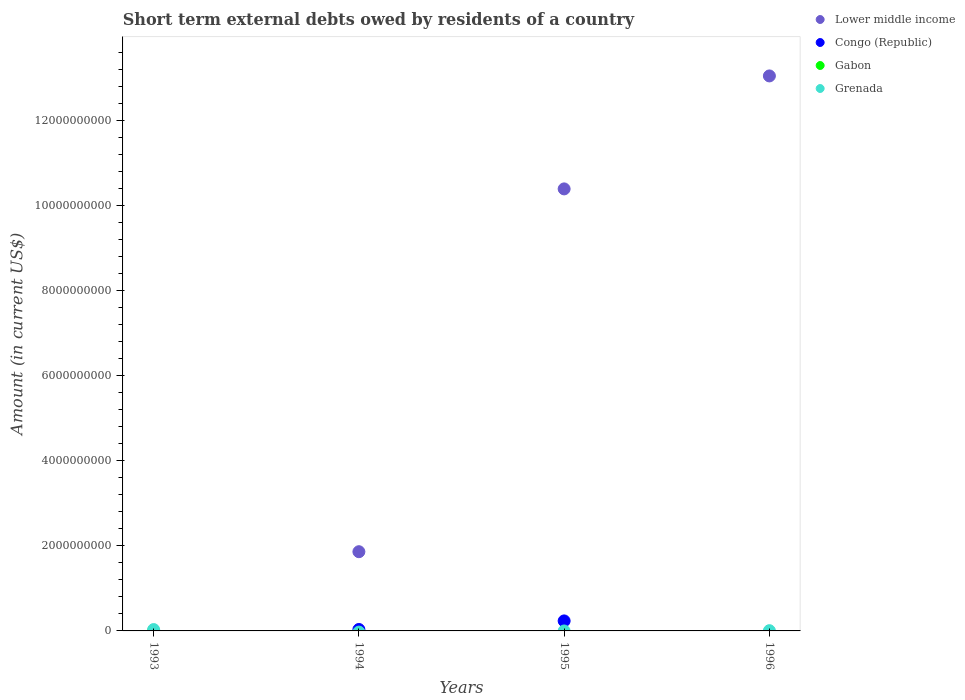How many different coloured dotlines are there?
Provide a succinct answer. 3. What is the amount of short-term external debts owed by residents in Grenada in 1995?
Provide a succinct answer. 0. Across all years, what is the maximum amount of short-term external debts owed by residents in Congo (Republic)?
Your response must be concise. 2.36e+08. Across all years, what is the minimum amount of short-term external debts owed by residents in Gabon?
Provide a succinct answer. 0. What is the total amount of short-term external debts owed by residents in Grenada in the graph?
Your answer should be compact. 3.74e+07. What is the difference between the amount of short-term external debts owed by residents in Grenada in 1993 and that in 1996?
Your response must be concise. 2.60e+07. What is the difference between the amount of short-term external debts owed by residents in Congo (Republic) in 1995 and the amount of short-term external debts owed by residents in Lower middle income in 1996?
Make the answer very short. -1.28e+1. What is the average amount of short-term external debts owed by residents in Grenada per year?
Your answer should be very brief. 9.34e+06. In the year 1994, what is the difference between the amount of short-term external debts owed by residents in Lower middle income and amount of short-term external debts owed by residents in Congo (Republic)?
Your answer should be very brief. 1.83e+09. In how many years, is the amount of short-term external debts owed by residents in Lower middle income greater than 9200000000 US$?
Offer a very short reply. 2. Is the amount of short-term external debts owed by residents in Lower middle income in 1994 less than that in 1996?
Your answer should be very brief. Yes. What is the difference between the highest and the lowest amount of short-term external debts owed by residents in Lower middle income?
Give a very brief answer. 1.31e+1. In how many years, is the amount of short-term external debts owed by residents in Congo (Republic) greater than the average amount of short-term external debts owed by residents in Congo (Republic) taken over all years?
Provide a short and direct response. 1. Is it the case that in every year, the sum of the amount of short-term external debts owed by residents in Congo (Republic) and amount of short-term external debts owed by residents in Gabon  is greater than the sum of amount of short-term external debts owed by residents in Grenada and amount of short-term external debts owed by residents in Lower middle income?
Give a very brief answer. No. Does the amount of short-term external debts owed by residents in Grenada monotonically increase over the years?
Offer a very short reply. No. Is the amount of short-term external debts owed by residents in Grenada strictly less than the amount of short-term external debts owed by residents in Gabon over the years?
Provide a short and direct response. No. How many years are there in the graph?
Make the answer very short. 4. Does the graph contain any zero values?
Offer a very short reply. Yes. Does the graph contain grids?
Offer a very short reply. No. Where does the legend appear in the graph?
Provide a succinct answer. Top right. How many legend labels are there?
Provide a short and direct response. 4. What is the title of the graph?
Offer a very short reply. Short term external debts owed by residents of a country. What is the label or title of the X-axis?
Your answer should be compact. Years. What is the label or title of the Y-axis?
Ensure brevity in your answer.  Amount (in current US$). What is the Amount (in current US$) of Grenada in 1993?
Offer a very short reply. 3.17e+07. What is the Amount (in current US$) in Lower middle income in 1994?
Make the answer very short. 1.86e+09. What is the Amount (in current US$) of Congo (Republic) in 1994?
Offer a very short reply. 3.41e+07. What is the Amount (in current US$) in Gabon in 1994?
Offer a very short reply. 0. What is the Amount (in current US$) in Grenada in 1994?
Provide a short and direct response. 0. What is the Amount (in current US$) of Lower middle income in 1995?
Ensure brevity in your answer.  1.04e+1. What is the Amount (in current US$) in Congo (Republic) in 1995?
Offer a very short reply. 2.36e+08. What is the Amount (in current US$) in Gabon in 1995?
Offer a very short reply. 0. What is the Amount (in current US$) in Grenada in 1995?
Give a very brief answer. 0. What is the Amount (in current US$) of Lower middle income in 1996?
Give a very brief answer. 1.31e+1. What is the Amount (in current US$) in Gabon in 1996?
Your answer should be very brief. 0. What is the Amount (in current US$) in Grenada in 1996?
Offer a terse response. 5.66e+06. Across all years, what is the maximum Amount (in current US$) of Lower middle income?
Ensure brevity in your answer.  1.31e+1. Across all years, what is the maximum Amount (in current US$) of Congo (Republic)?
Ensure brevity in your answer.  2.36e+08. Across all years, what is the maximum Amount (in current US$) in Grenada?
Give a very brief answer. 3.17e+07. Across all years, what is the minimum Amount (in current US$) in Lower middle income?
Provide a succinct answer. 0. Across all years, what is the minimum Amount (in current US$) of Congo (Republic)?
Your answer should be compact. 0. Across all years, what is the minimum Amount (in current US$) of Grenada?
Ensure brevity in your answer.  0. What is the total Amount (in current US$) in Lower middle income in the graph?
Keep it short and to the point. 2.53e+1. What is the total Amount (in current US$) in Congo (Republic) in the graph?
Provide a succinct answer. 2.70e+08. What is the total Amount (in current US$) of Gabon in the graph?
Your answer should be compact. 0. What is the total Amount (in current US$) in Grenada in the graph?
Your answer should be compact. 3.74e+07. What is the difference between the Amount (in current US$) in Grenada in 1993 and that in 1996?
Your answer should be very brief. 2.60e+07. What is the difference between the Amount (in current US$) in Lower middle income in 1994 and that in 1995?
Give a very brief answer. -8.54e+09. What is the difference between the Amount (in current US$) of Congo (Republic) in 1994 and that in 1995?
Your response must be concise. -2.02e+08. What is the difference between the Amount (in current US$) of Lower middle income in 1994 and that in 1996?
Provide a short and direct response. -1.12e+1. What is the difference between the Amount (in current US$) of Lower middle income in 1995 and that in 1996?
Keep it short and to the point. -2.66e+09. What is the difference between the Amount (in current US$) in Lower middle income in 1994 and the Amount (in current US$) in Congo (Republic) in 1995?
Ensure brevity in your answer.  1.63e+09. What is the difference between the Amount (in current US$) of Lower middle income in 1994 and the Amount (in current US$) of Grenada in 1996?
Keep it short and to the point. 1.86e+09. What is the difference between the Amount (in current US$) in Congo (Republic) in 1994 and the Amount (in current US$) in Grenada in 1996?
Provide a succinct answer. 2.84e+07. What is the difference between the Amount (in current US$) of Lower middle income in 1995 and the Amount (in current US$) of Grenada in 1996?
Provide a short and direct response. 1.04e+1. What is the difference between the Amount (in current US$) of Congo (Republic) in 1995 and the Amount (in current US$) of Grenada in 1996?
Offer a very short reply. 2.30e+08. What is the average Amount (in current US$) in Lower middle income per year?
Provide a short and direct response. 6.33e+09. What is the average Amount (in current US$) in Congo (Republic) per year?
Ensure brevity in your answer.  6.74e+07. What is the average Amount (in current US$) of Grenada per year?
Provide a short and direct response. 9.34e+06. In the year 1994, what is the difference between the Amount (in current US$) in Lower middle income and Amount (in current US$) in Congo (Republic)?
Give a very brief answer. 1.83e+09. In the year 1995, what is the difference between the Amount (in current US$) of Lower middle income and Amount (in current US$) of Congo (Republic)?
Offer a very short reply. 1.02e+1. In the year 1996, what is the difference between the Amount (in current US$) of Lower middle income and Amount (in current US$) of Grenada?
Keep it short and to the point. 1.31e+1. What is the ratio of the Amount (in current US$) of Grenada in 1993 to that in 1996?
Provide a short and direct response. 5.6. What is the ratio of the Amount (in current US$) in Lower middle income in 1994 to that in 1995?
Give a very brief answer. 0.18. What is the ratio of the Amount (in current US$) of Congo (Republic) in 1994 to that in 1995?
Provide a succinct answer. 0.14. What is the ratio of the Amount (in current US$) in Lower middle income in 1994 to that in 1996?
Your answer should be very brief. 0.14. What is the ratio of the Amount (in current US$) of Lower middle income in 1995 to that in 1996?
Your response must be concise. 0.8. What is the difference between the highest and the second highest Amount (in current US$) of Lower middle income?
Provide a short and direct response. 2.66e+09. What is the difference between the highest and the lowest Amount (in current US$) in Lower middle income?
Offer a terse response. 1.31e+1. What is the difference between the highest and the lowest Amount (in current US$) in Congo (Republic)?
Your answer should be very brief. 2.36e+08. What is the difference between the highest and the lowest Amount (in current US$) in Grenada?
Provide a short and direct response. 3.17e+07. 